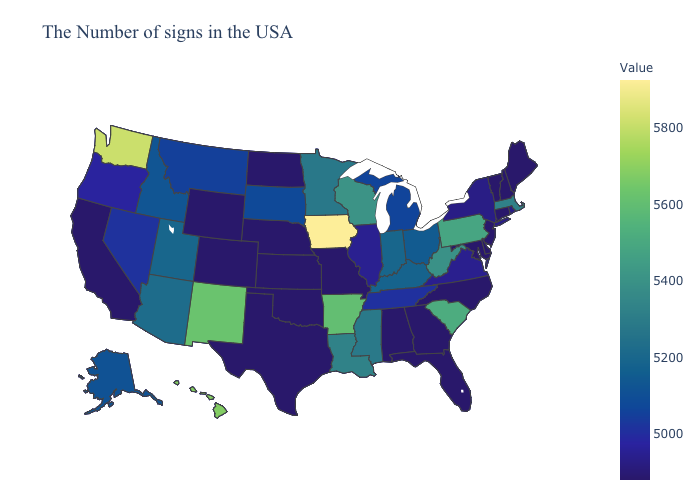Which states have the lowest value in the MidWest?
Give a very brief answer. Missouri, Kansas, Nebraska, North Dakota. Does Alaska have the lowest value in the USA?
Keep it brief. No. Does North Dakota have the lowest value in the MidWest?
Quick response, please. Yes. Among the states that border New Hampshire , which have the highest value?
Answer briefly. Massachusetts. Does Alabama have the lowest value in the South?
Answer briefly. Yes. 